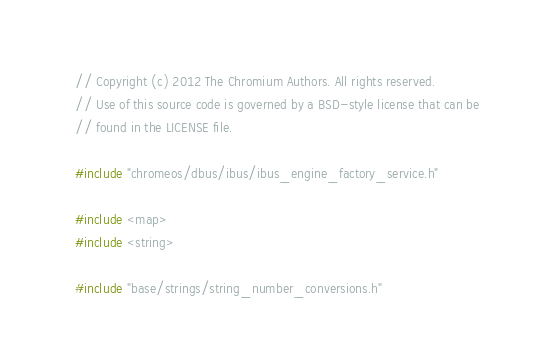Convert code to text. <code><loc_0><loc_0><loc_500><loc_500><_C++_>// Copyright (c) 2012 The Chromium Authors. All rights reserved.
// Use of this source code is governed by a BSD-style license that can be
// found in the LICENSE file.

#include "chromeos/dbus/ibus/ibus_engine_factory_service.h"

#include <map>
#include <string>

#include "base/strings/string_number_conversions.h"</code> 